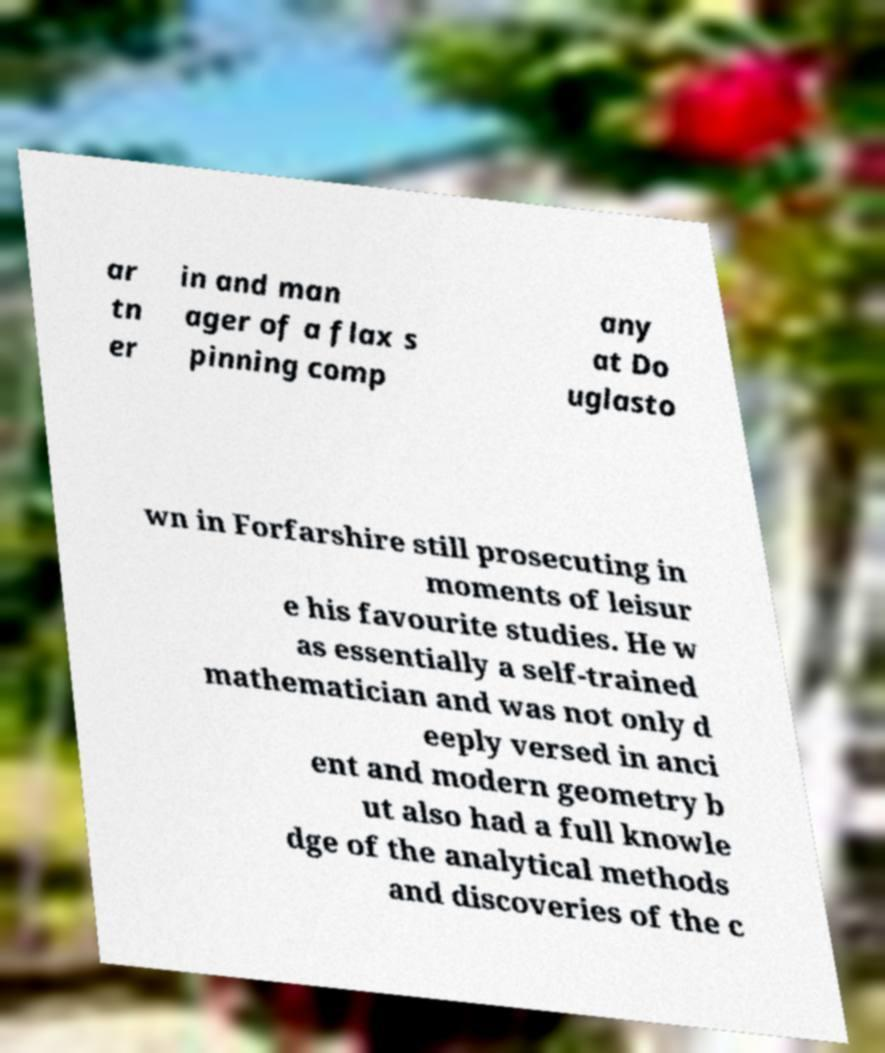For documentation purposes, I need the text within this image transcribed. Could you provide that? ar tn er in and man ager of a flax s pinning comp any at Do uglasto wn in Forfarshire still prosecuting in moments of leisur e his favourite studies. He w as essentially a self-trained mathematician and was not only d eeply versed in anci ent and modern geometry b ut also had a full knowle dge of the analytical methods and discoveries of the c 